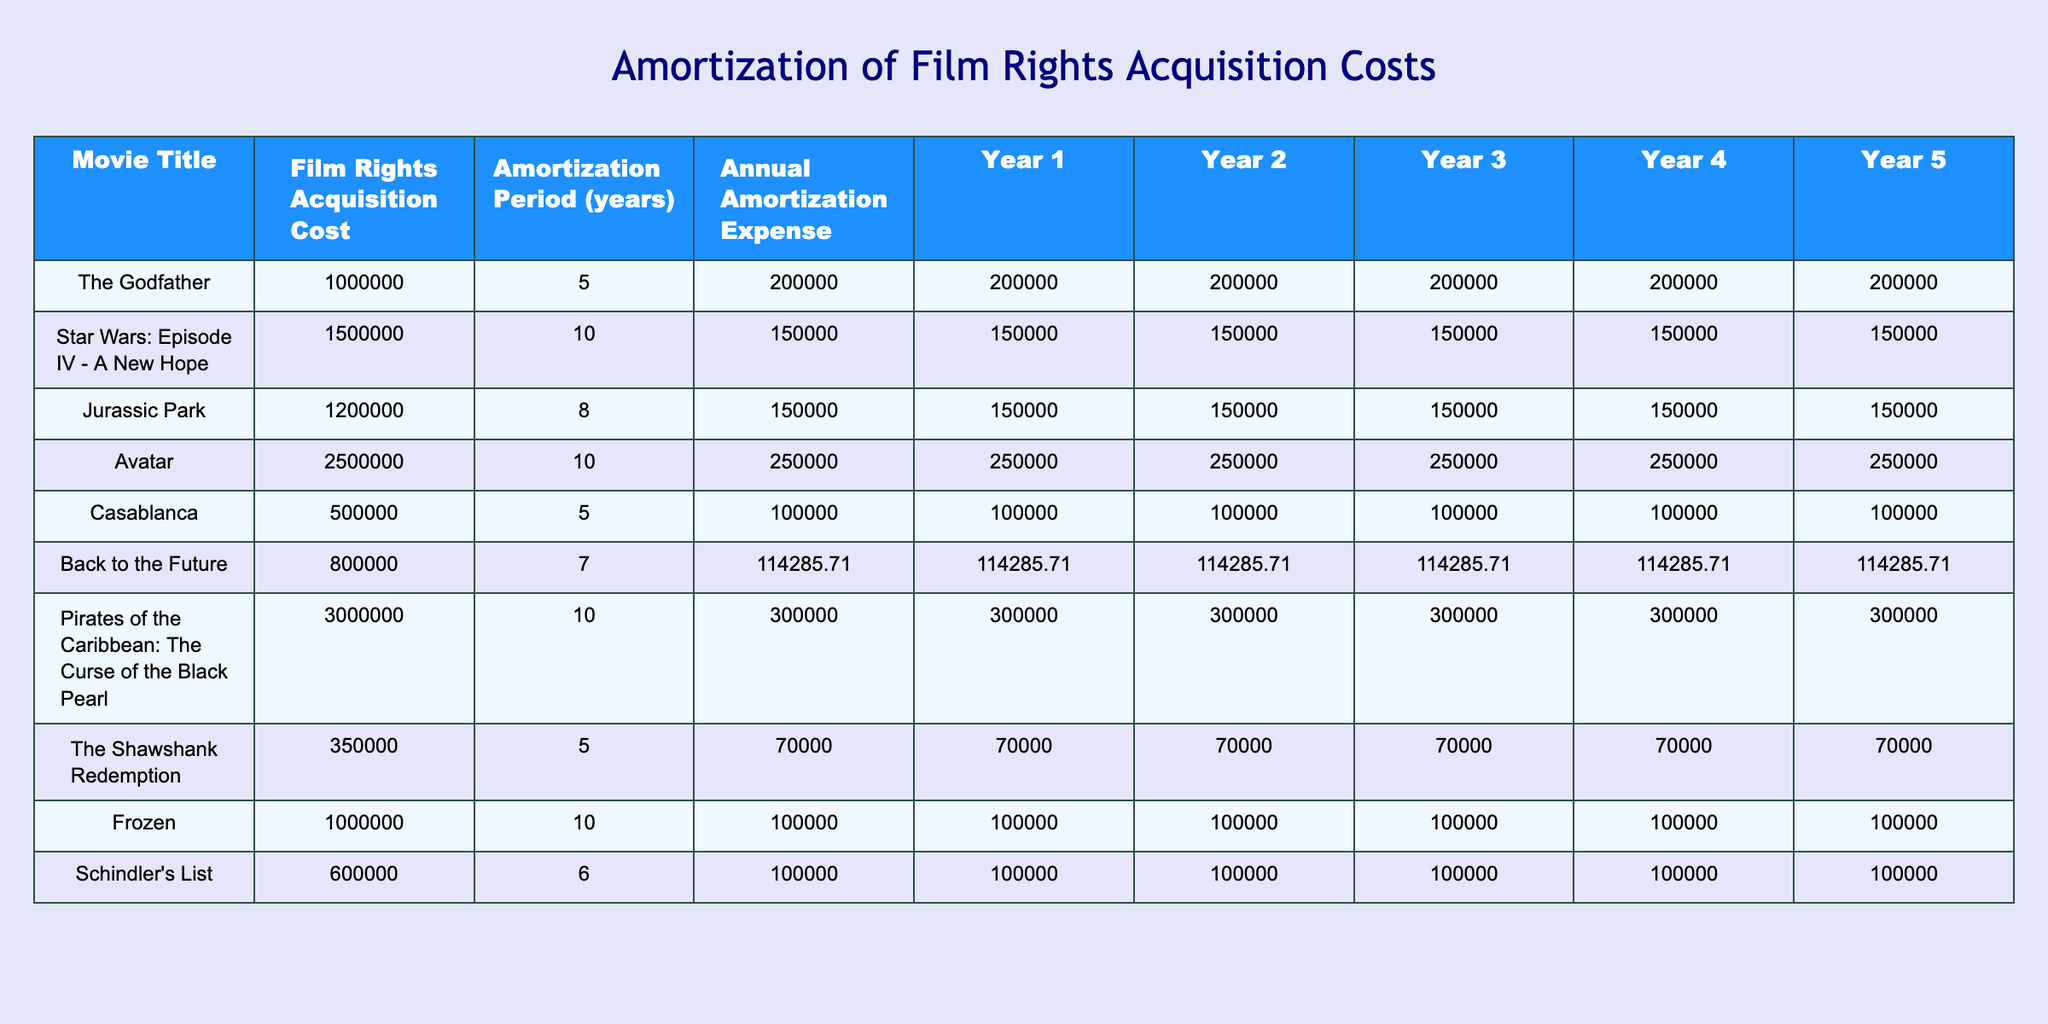What is the film rights acquisition cost for "Avatar"? The table lists "Avatar" under the Movie Title column, where the corresponding Film Rights Acquisition Cost is noted as 2500000.
Answer: 2500000 How much is the annual amortization expense for "Star Wars: Episode IV - A New Hope"? In the table, the row for "Star Wars: Episode IV - A New Hope" shows the Annual Amortization Expense value as 150000.
Answer: 150000 What is the total amortization expense for "The Shawshank Redemption" over its amortization period? For "The Shawshank Redemption," the Annual Amortization Expense is 70000, and the amortization period is 5 years. Therefore, total amortization is 70000 * 5 = 350000.
Answer: 350000 Is the annual amortization expense for "Frozen" more than the annual amortization expense for "Casablanca"? The table shows that the annual amortization expense for "Frozen" is 100000 and for "Casablanca" is also 100000. Since these values are equal, the answer is no.
Answer: No Which movie has the highest total amortization expense over its amortization period, and what is that amount? "Pirates of the Caribbean: The Curse of the Black Pearl" has a Film Rights Acquisition Cost of 3000000 and an amortization period of 10 years with an annual amortization expense of 300000. Total amortization expense is 300000 * 10 = 3000000, which is the highest amount among the movies listed.
Answer: Pirates of the Caribbean: The Curse of the Black Pearl, 3000000 What is the average annual amortization expense across all movies listed in the table? To find the average, first, sum all annual amortization expenses: 200000 + 150000 + 150000 + 250000 + 100000 + 114285.71 + 300000 + 70000 + 100000 + 100000 = 1464285.71. Then divide by the number of movies (10): 1464285.71 / 10 = 146428.57, which rounds to approximately 146429.
Answer: 146429 For which movie is the amortization period the shortest, and how many years is it? By reviewing the Amortization Period column, "The Shawshank Redemption" has the shortest period at 5 years, among the movies listed in the table.
Answer: The Shawshank Redemption, 5 years What is the difference in film rights acquisition cost between "Jurassic Park" and "The Godfather"? "Jurassic Park" has a cost of 1200000, and "The Godfather" has a cost of 1000000. The difference is calculated as 1200000 - 1000000 = 200000.
Answer: 200000 